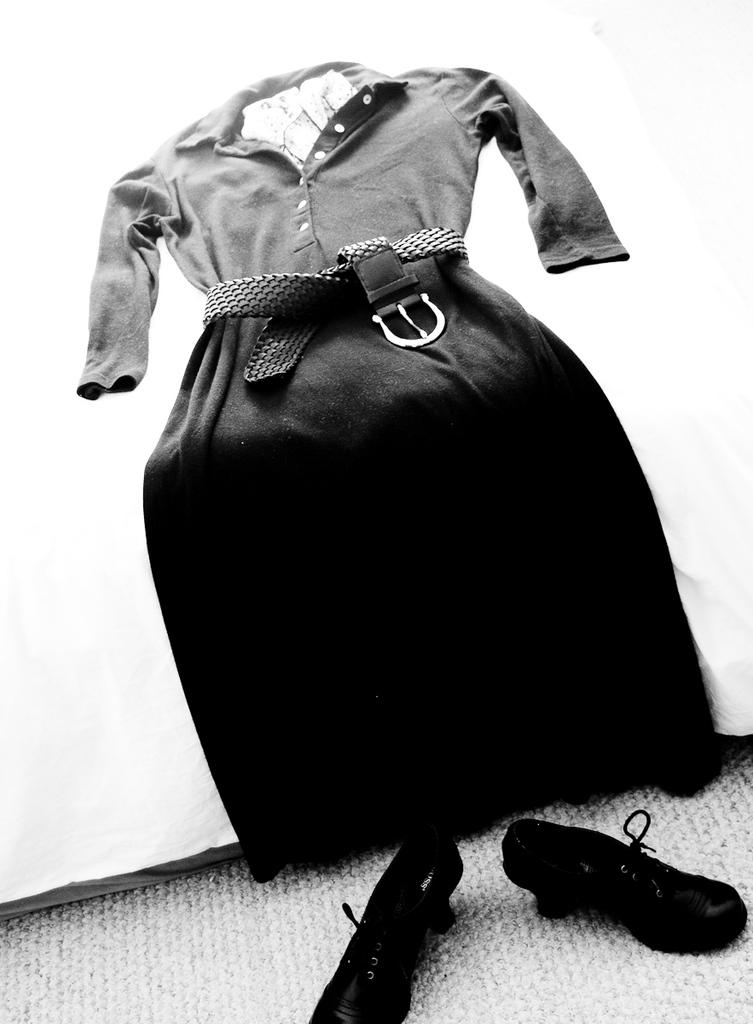What is the main subject in the center of the image? There is a cocktail dress in the center of the image. What else can be seen at the bottom side of the image? There are shoes at the bottom side of the image. What type of rabbit can be seen playing with a wire in the image? There is no rabbit or wire present in the image; it only features a cocktail dress and shoes. What material is the leather used for in the image? There is no leather present in the image. 